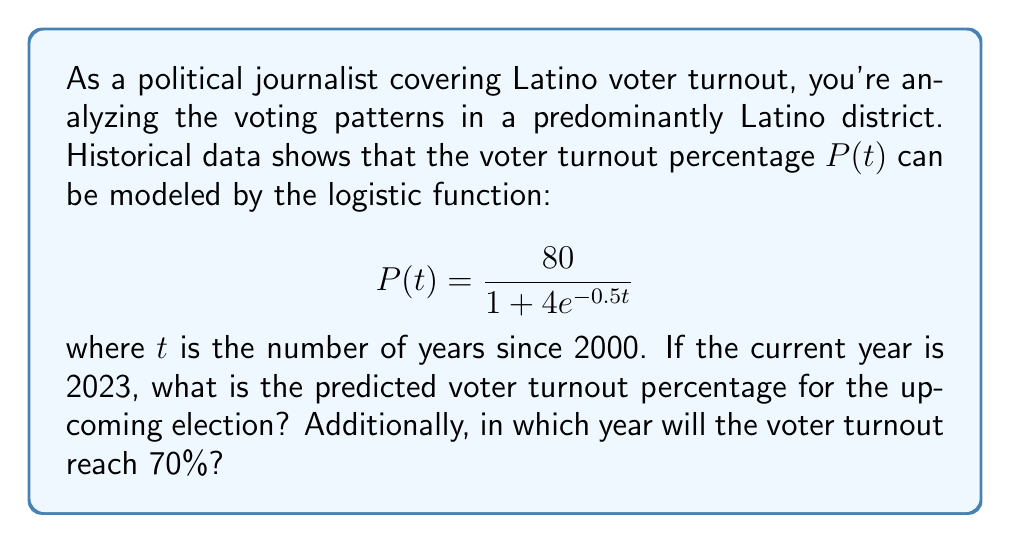Provide a solution to this math problem. To solve this problem, we'll follow these steps:

1. Calculate the predicted voter turnout for 2023:
   - The current year is 2023, so $t = 2023 - 2000 = 23$
   - Substitute $t = 23$ into the logistic function:
     $$P(23) = \frac{80}{1 + 4e^{-0.5(23)}} = \frac{80}{1 + 4e^{-11.5}}$$
   - Calculate this value: $P(23) \approx 79.28\%$

2. Find the year when voter turnout reaches 70%:
   - Set up the equation: $70 = \frac{80}{1 + 4e^{-0.5t}}$
   - Solve for $t$:
     $$70(1 + 4e^{-0.5t}) = 80$$
     $$70 + 280e^{-0.5t} = 80$$
     $$280e^{-0.5t} = 10$$
     $$e^{-0.5t} = \frac{1}{28}$$
     $$-0.5t = \ln(\frac{1}{28})$$
     $$t = -2\ln(\frac{1}{28}) \approx 6.63$$
   - Since $t$ represents years since 2000, add 6.63 to 2000:
     $2000 + 6.63 \approx 2006.63$

Therefore, voter turnout will reach 70% in 2007 (rounding up to the nearest year).
Answer: The predicted voter turnout for the 2023 election is approximately 79.28%. The voter turnout will reach 70% in 2007. 